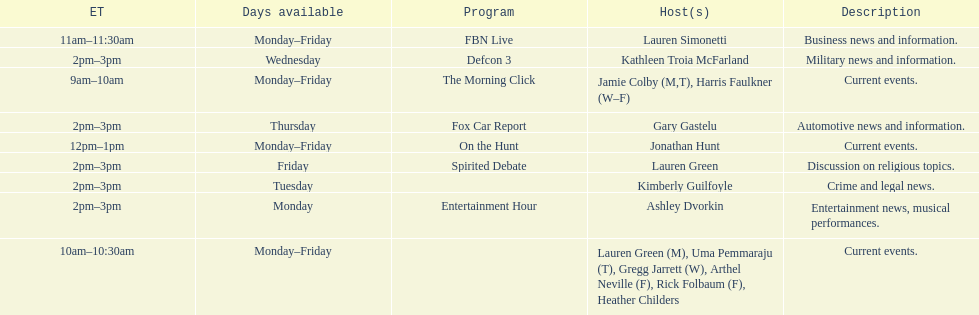How long does on the hunt run? 1 hour. 